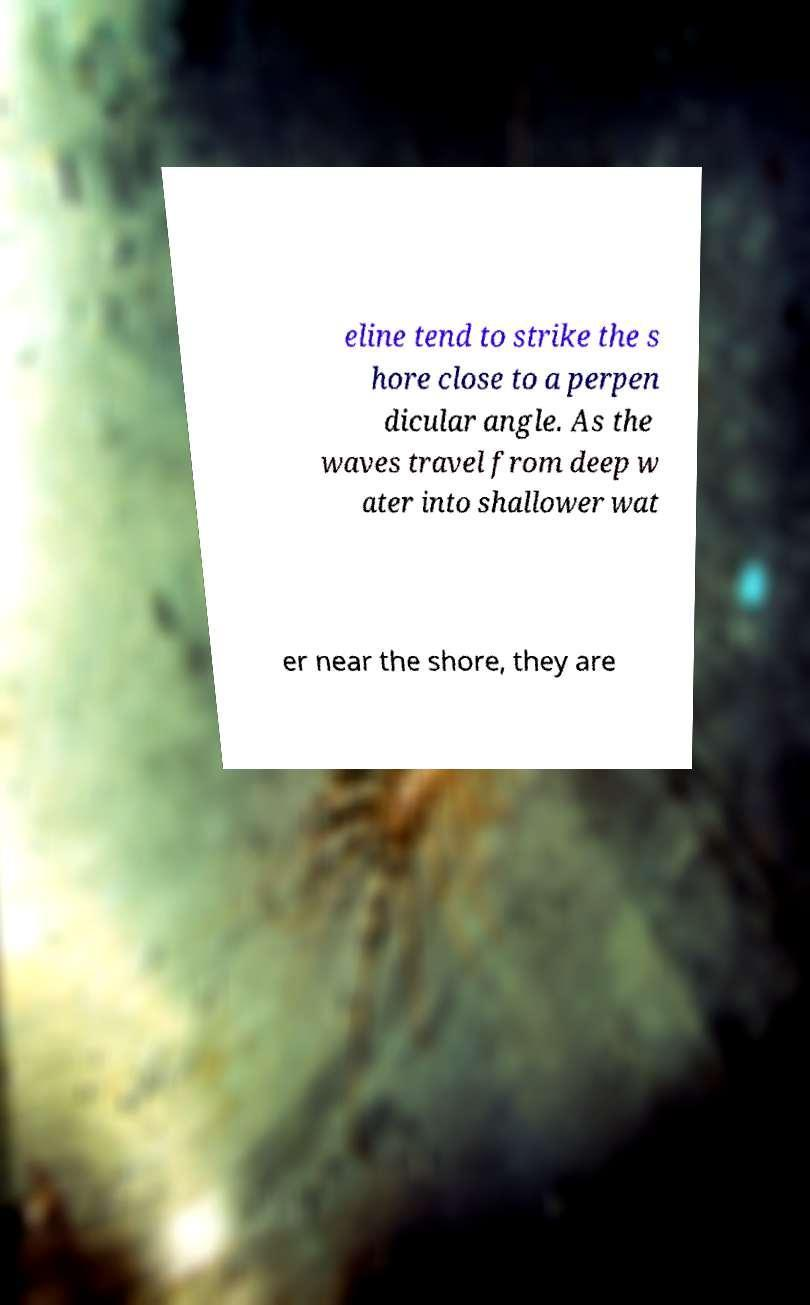Could you assist in decoding the text presented in this image and type it out clearly? eline tend to strike the s hore close to a perpen dicular angle. As the waves travel from deep w ater into shallower wat er near the shore, they are 